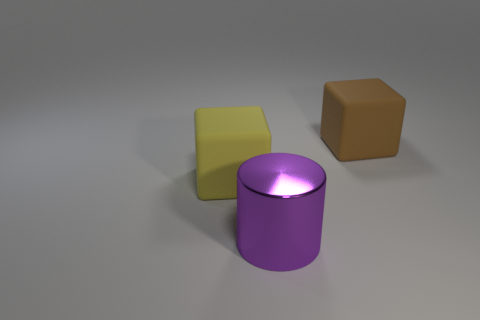Add 2 tiny red metallic balls. How many objects exist? 5 Subtract all cylinders. How many objects are left? 2 Add 1 purple cylinders. How many purple cylinders are left? 2 Add 1 yellow matte cylinders. How many yellow matte cylinders exist? 1 Subtract 1 brown cubes. How many objects are left? 2 Subtract all red cylinders. Subtract all gray balls. How many cylinders are left? 1 Subtract all shiny cylinders. Subtract all big metal cylinders. How many objects are left? 1 